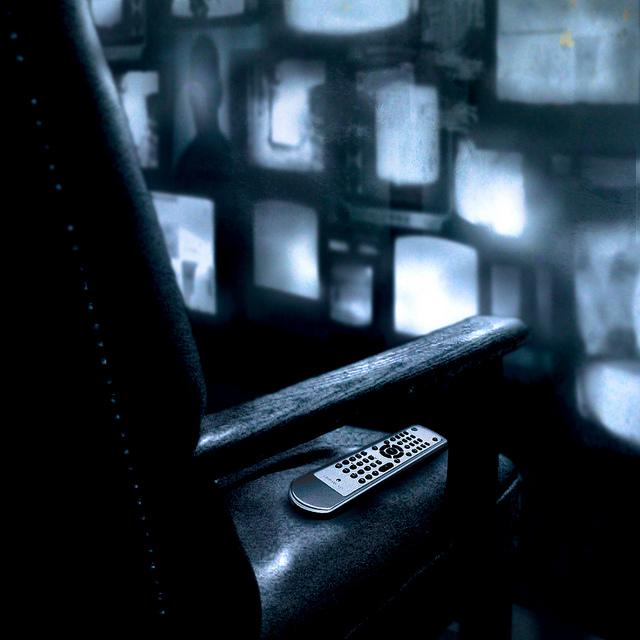Is this a color photo?
Concise answer only. No. What is the device on the chair used for?
Answer briefly. Changing channels. What is the chair seat made of?
Give a very brief answer. Leather. 